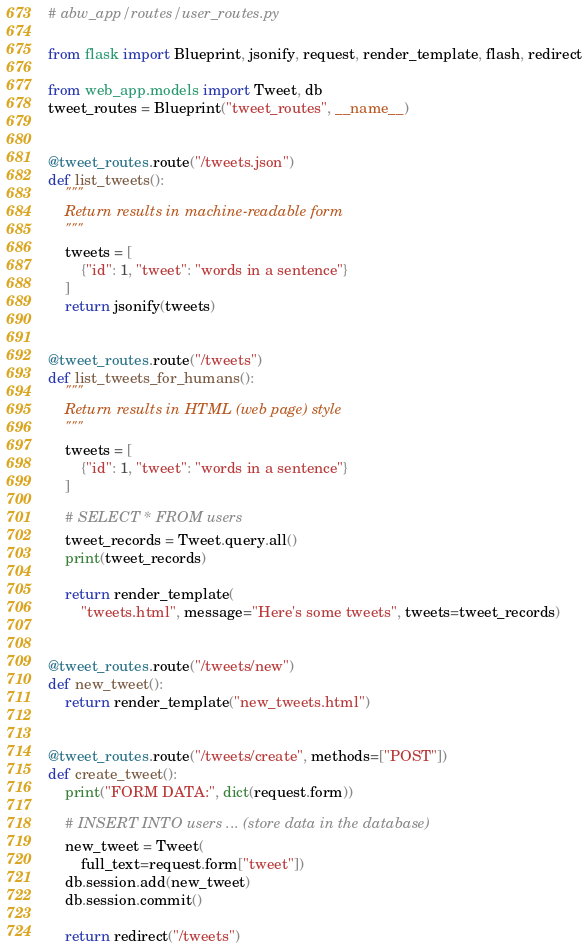Convert code to text. <code><loc_0><loc_0><loc_500><loc_500><_Python_># abw_app/routes/user_routes.py

from flask import Blueprint, jsonify, request, render_template, flash, redirect

from web_app.models import Tweet, db
tweet_routes = Blueprint("tweet_routes", __name__)


@tweet_routes.route("/tweets.json")
def list_tweets():
    """
    Return results in machine-readable form
    """
    tweets = [
        {"id": 1, "tweet": "words in a sentence"}
    ]
    return jsonify(tweets)


@tweet_routes.route("/tweets")
def list_tweets_for_humans():
    """
    Return results in HTML (web page) style
    """
    tweets = [
        {"id": 1, "tweet": "words in a sentence"}
    ]

    # SELECT * FROM users
    tweet_records = Tweet.query.all()
    print(tweet_records)

    return render_template(
        "tweets.html", message="Here's some tweets", tweets=tweet_records)


@tweet_routes.route("/tweets/new")
def new_tweet():
    return render_template("new_tweets.html")


@tweet_routes.route("/tweets/create", methods=["POST"])
def create_tweet():
    print("FORM DATA:", dict(request.form))

    # INSERT INTO users ... (store data in the database)
    new_tweet = Tweet(
        full_text=request.form["tweet"])
    db.session.add(new_tweet)
    db.session.commit()

    return redirect("/tweets")
</code> 